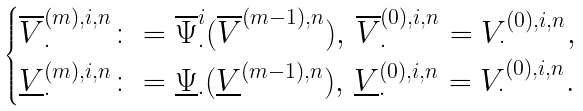<formula> <loc_0><loc_0><loc_500><loc_500>\begin{cases} \overline { V } _ { \cdot } ^ { ( m ) , i , n } \colon = \overline { \Psi } _ { \cdot } ^ { i } ( \overline { V } ^ { ( m - 1 ) , n } ) , \, \overline { V } _ { \cdot } ^ { ( 0 ) , i , n } = V _ { \cdot } ^ { ( 0 ) , i , n } , \\ \underline { V } _ { \cdot } ^ { ( m ) , i , n } \colon = \underline { \Psi } _ { \cdot } ( \underline { V } ^ { ( m - 1 ) , n } ) , \, \underline { V } _ { \cdot } ^ { ( 0 ) , i , n } = V _ { \cdot } ^ { ( 0 ) , i , n } . \end{cases}</formula> 